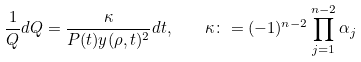Convert formula to latex. <formula><loc_0><loc_0><loc_500><loc_500>\frac { 1 } { Q } { d Q } = \frac { \kappa } { P ( t ) y ( \rho , t ) ^ { 2 } } d t , \quad \kappa \colon = ( - 1 ) ^ { n - 2 } \prod _ { j = 1 } ^ { n - 2 } { \alpha _ { j } }</formula> 